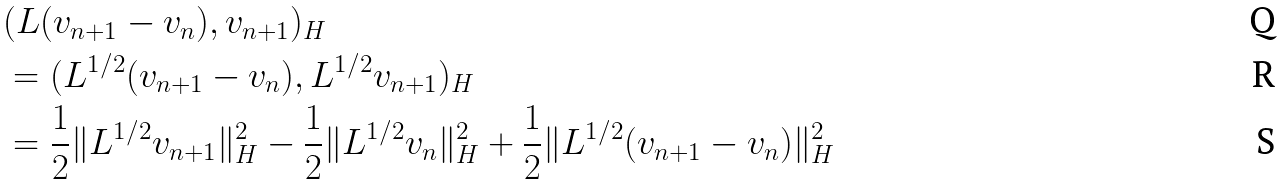Convert formula to latex. <formula><loc_0><loc_0><loc_500><loc_500>& ( L ( v _ { n + 1 } - v _ { n } ) , v _ { n + 1 } ) _ { H } \\ & = ( L ^ { 1 / 2 } ( v _ { n + 1 } - v _ { n } ) , L ^ { 1 / 2 } v _ { n + 1 } ) _ { H } \\ & = \frac { 1 } { 2 } \| L ^ { 1 / 2 } v _ { n + 1 } \| _ { H } ^ { 2 } - \frac { 1 } { 2 } \| L ^ { 1 / 2 } v _ { n } \| _ { H } ^ { 2 } + \frac { 1 } { 2 } \| L ^ { 1 / 2 } ( v _ { n + 1 } - v _ { n } ) \| _ { H } ^ { 2 }</formula> 